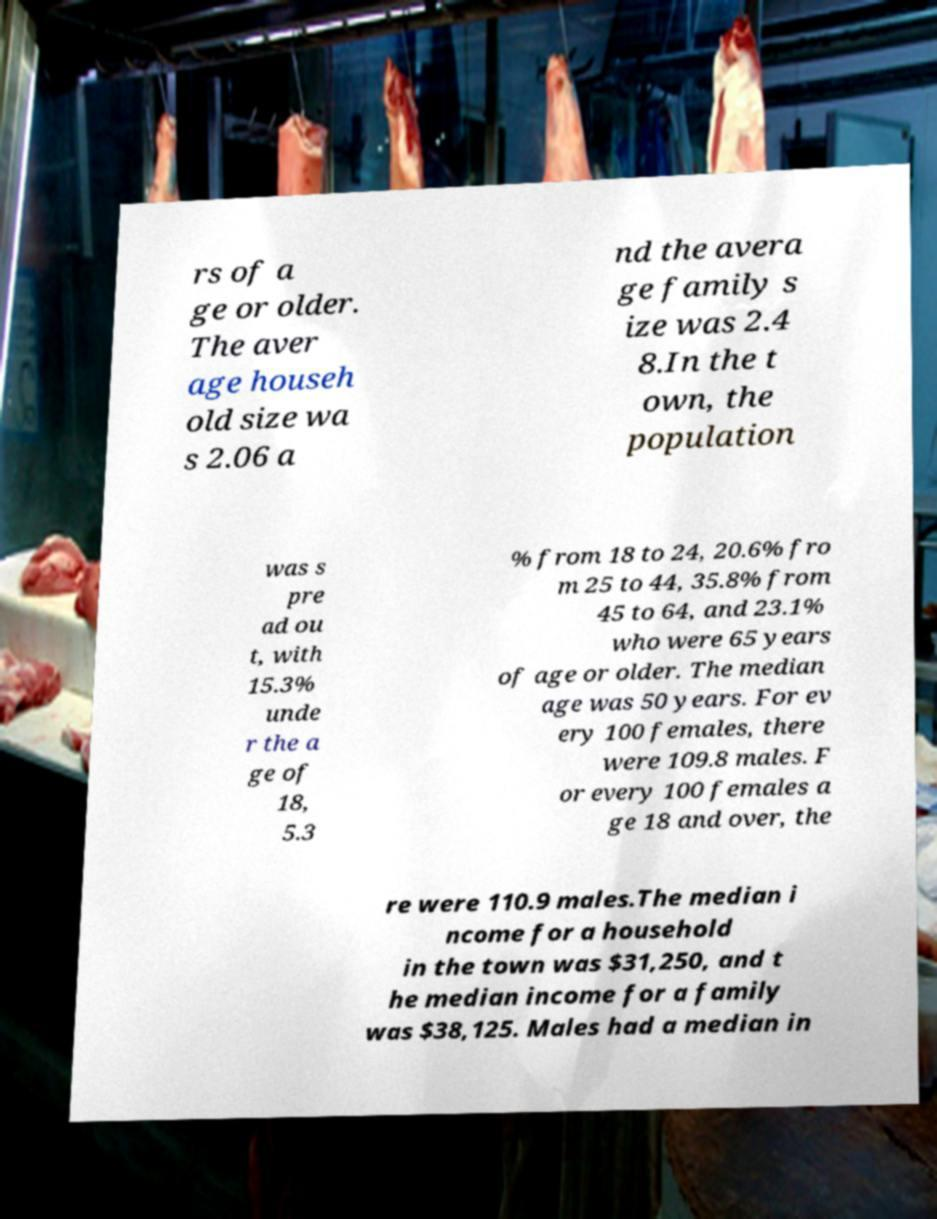Please read and relay the text visible in this image. What does it say? rs of a ge or older. The aver age househ old size wa s 2.06 a nd the avera ge family s ize was 2.4 8.In the t own, the population was s pre ad ou t, with 15.3% unde r the a ge of 18, 5.3 % from 18 to 24, 20.6% fro m 25 to 44, 35.8% from 45 to 64, and 23.1% who were 65 years of age or older. The median age was 50 years. For ev ery 100 females, there were 109.8 males. F or every 100 females a ge 18 and over, the re were 110.9 males.The median i ncome for a household in the town was $31,250, and t he median income for a family was $38,125. Males had a median in 